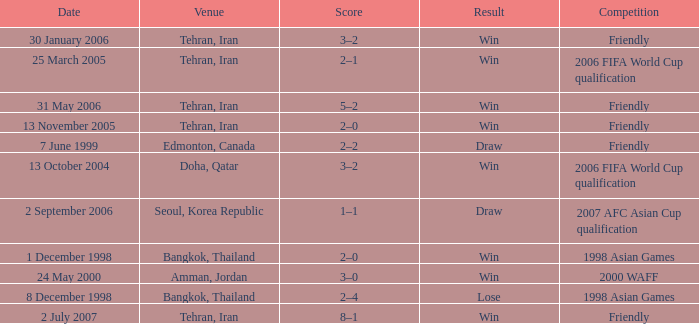What was the competition on 13 November 2005? Friendly. 